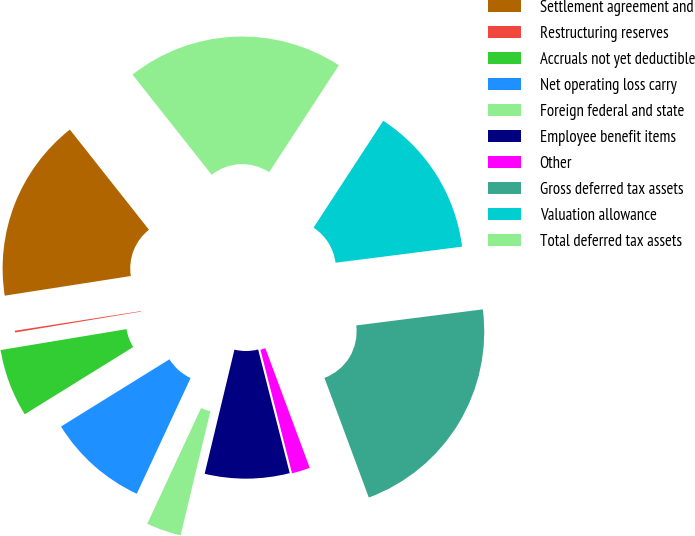Convert chart to OTSL. <chart><loc_0><loc_0><loc_500><loc_500><pie_chart><fcel>Settlement agreement and<fcel>Restructuring reserves<fcel>Accruals not yet deductible<fcel>Net operating loss carry<fcel>Foreign federal and state<fcel>Employee benefit items<fcel>Other<fcel>Gross deferred tax assets<fcel>Valuation allowance<fcel>Total deferred tax assets<nl><fcel>16.82%<fcel>0.16%<fcel>6.21%<fcel>9.24%<fcel>3.18%<fcel>7.73%<fcel>1.67%<fcel>21.36%<fcel>13.79%<fcel>19.84%<nl></chart> 